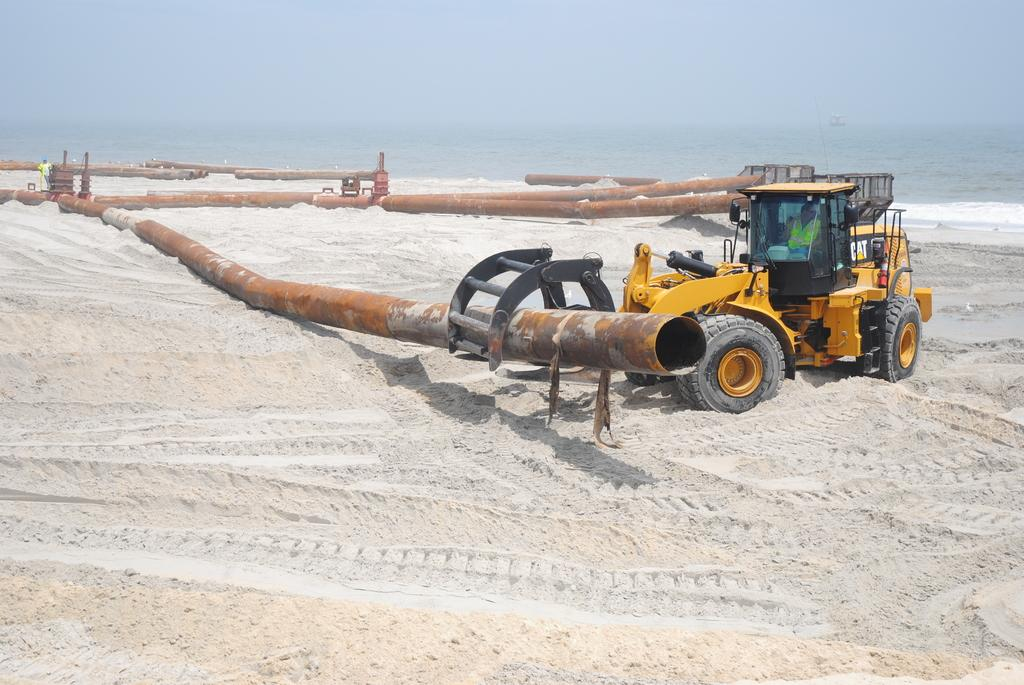What type of vehicle is on the right side of the image? There is a JCB in yellow color on the right side of the image. What can be seen besides the JCB in the image? There are iron pipes in the image. What natural feature is visible in the background of the image? The sea is visible at the back side of the image. What type of silk is draped over the JCB in the image? There is no silk present in the image; it features a JCB, iron pipes, and the sea in the background. What kind of ornament is hanging from the iron pipes in the image? There are no ornaments hanging from the iron pipes in the image; only the pipes themselves are visible. 